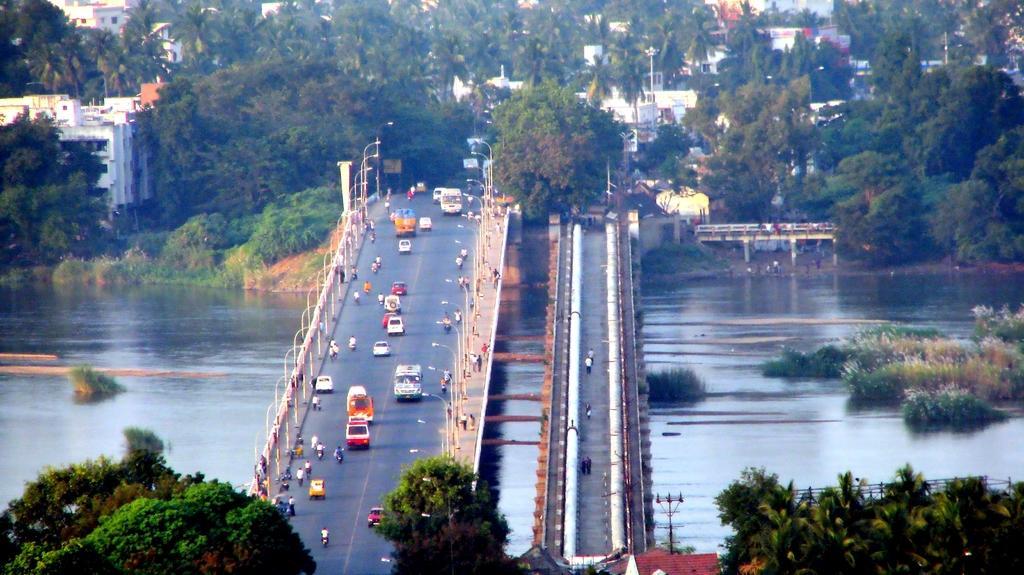Could you give a brief overview of what you see in this image? In this picture we can see truck, bus, vehicles and persons on the bridge. Beside that we can see two pipes. On the left we can see the water. In the background we can see buildings, poles, street lights and trees. On the right we can see the group of persons were standing near to the water, beside them we can see another bridge. At the bottom we can see electric pole and wires are connected to it. 